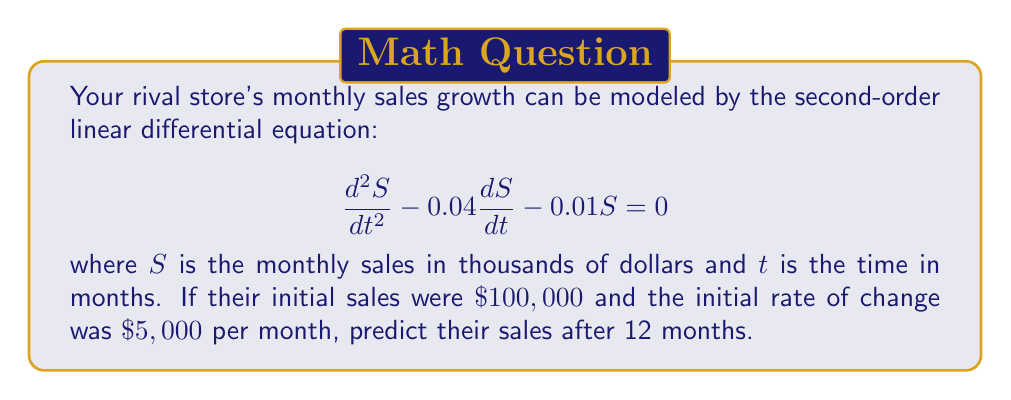Could you help me with this problem? To solve this problem, we need to follow these steps:

1) The general solution to this second-order linear differential equation is:

   $$S(t) = C_1e^{r_1t} + C_2e^{r_2t}$$

   where $r_1$ and $r_2$ are the roots of the characteristic equation.

2) The characteristic equation is:
   
   $$r^2 - 0.04r - 0.01 = 0$$

3) Solving this quadratic equation:
   
   $$r = \frac{0.04 \pm \sqrt{0.04^2 + 4(0.01)}}{2} = \frac{0.04 \pm 0.2}{2}$$

   $$r_1 = 0.12 \text{ and } r_2 = -0.08$$

4) Therefore, the general solution is:

   $$S(t) = C_1e^{0.12t} + C_2e^{-0.08t}$$

5) We need to find $C_1$ and $C_2$ using the initial conditions:

   At $t=0$, $S(0) = 100$ and $S'(0) = 5$

6) From $S(0) = 100$:
   
   $$100 = C_1 + C_2$$

7) From $S'(0) = 5$:
   
   $$5 = 0.12C_1 - 0.08C_2$$

8) Solving these simultaneous equations:

   $$C_1 = 75 \text{ and } C_2 = 25$$

9) Therefore, the particular solution is:

   $$S(t) = 75e^{0.12t} + 25e^{-0.08t}$$

10) To find the sales after 12 months, we substitute $t=12$:

    $$S(12) = 75e^{0.12(12)} + 25e^{-0.08(12)}$$
    $$= 75e^{1.44} + 25e^{-0.96}$$
    $$\approx 318.02 + 9.57$$
    $$\approx 327.59$$
Answer: After 12 months, the rival store's sales will be approximately $\$327,590$. 